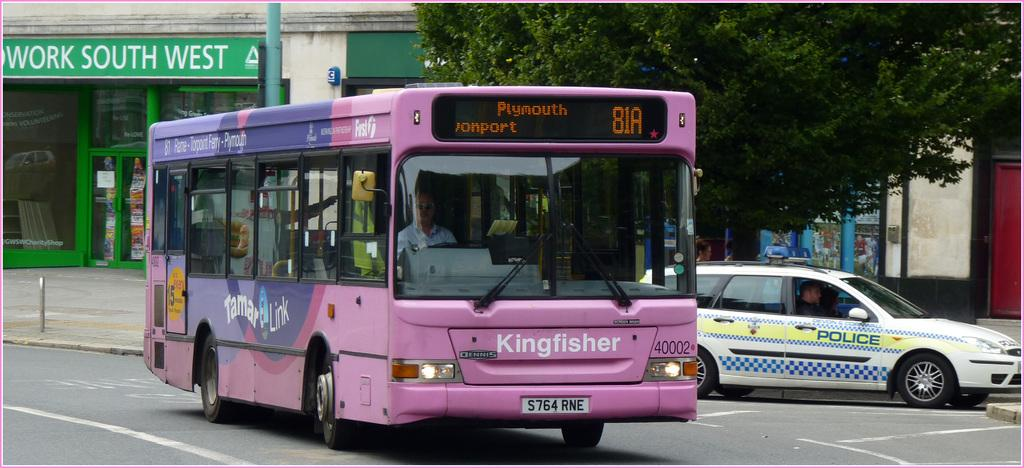<image>
Share a concise interpretation of the image provided. A purple kingfisher bus is destined to go to Plymouth. 